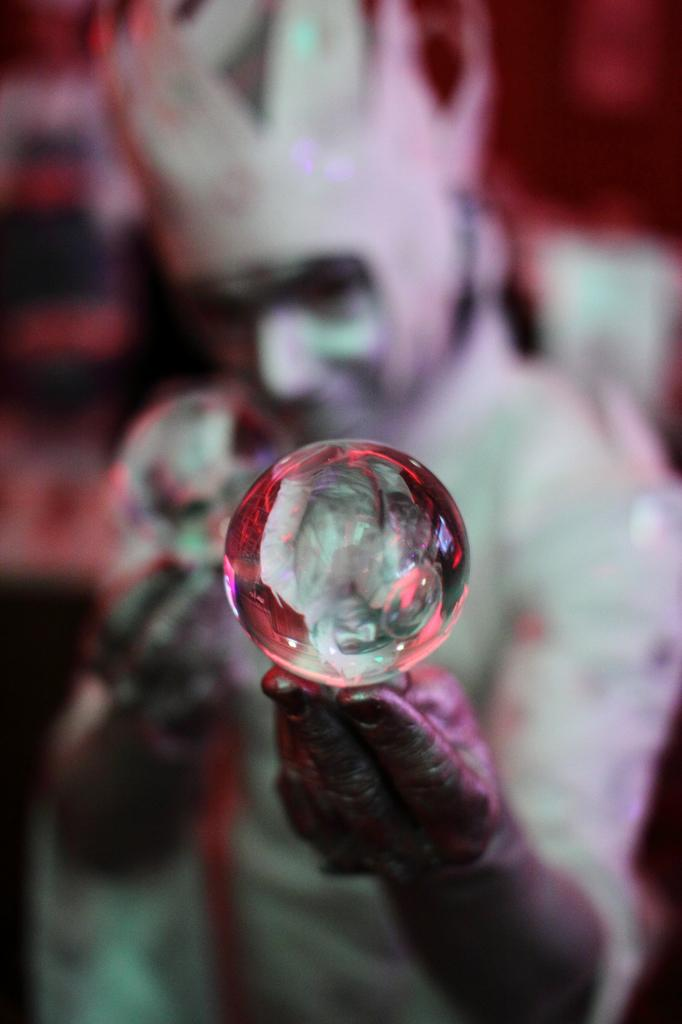What is the main subject in the foreground of the image? There is a person in the foreground of the image. What is the person holding in their hand? The person is holding a transparent ball in their hand. Can you describe the background of the image? The background of the image is blurred. What type of advice is the person giving in the image? There is no indication in the image that the person is giving advice, as the focus is on the person holding a transparent ball. 